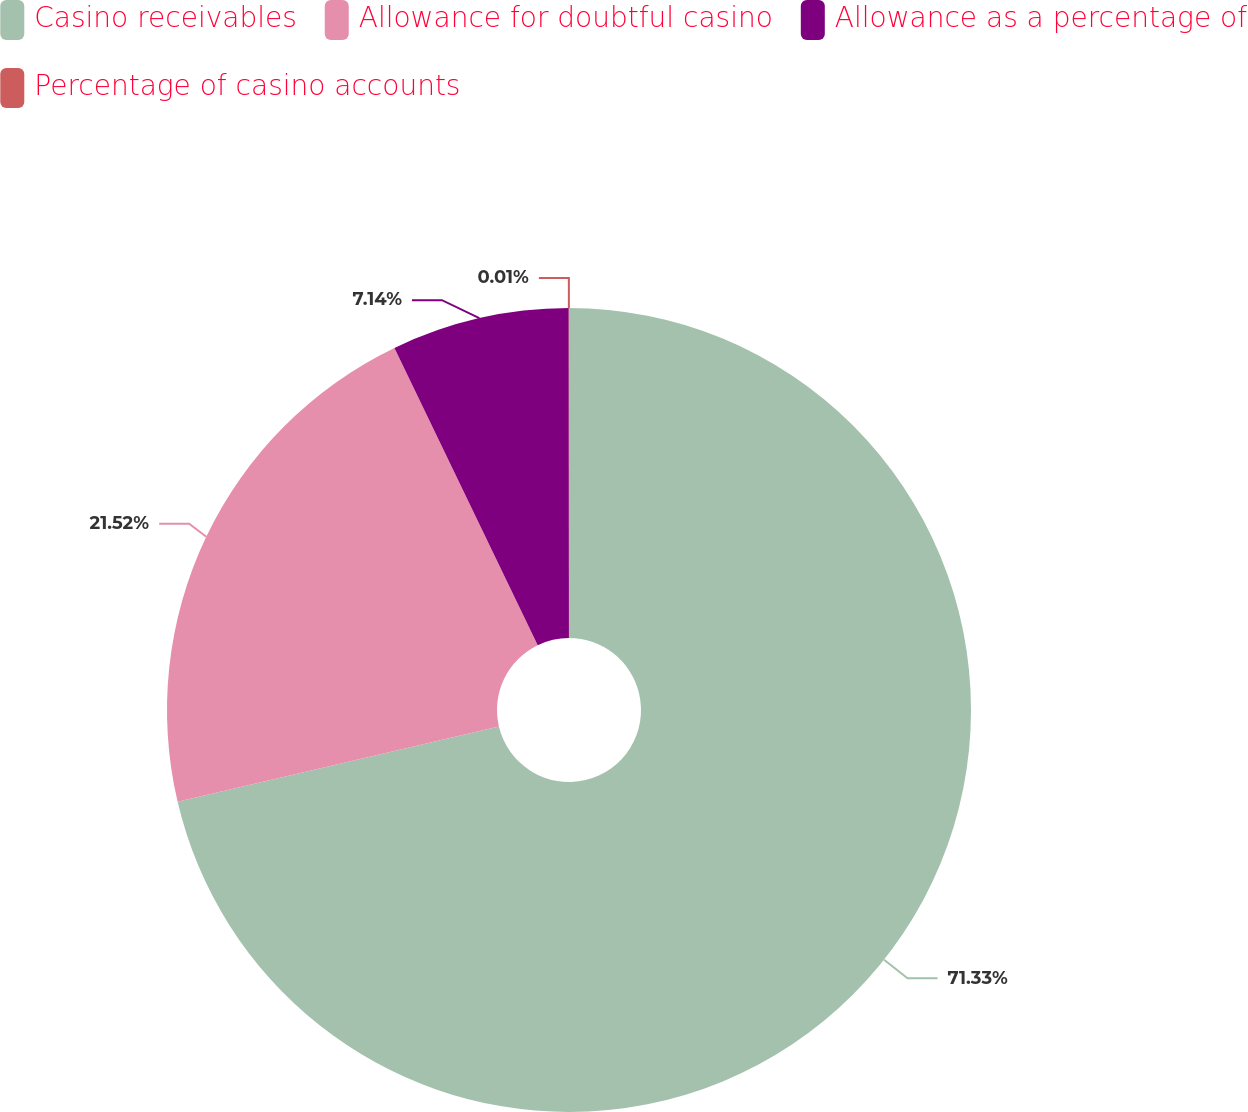Convert chart to OTSL. <chart><loc_0><loc_0><loc_500><loc_500><pie_chart><fcel>Casino receivables<fcel>Allowance for doubtful casino<fcel>Allowance as a percentage of<fcel>Percentage of casino accounts<nl><fcel>71.34%<fcel>21.52%<fcel>7.14%<fcel>0.01%<nl></chart> 